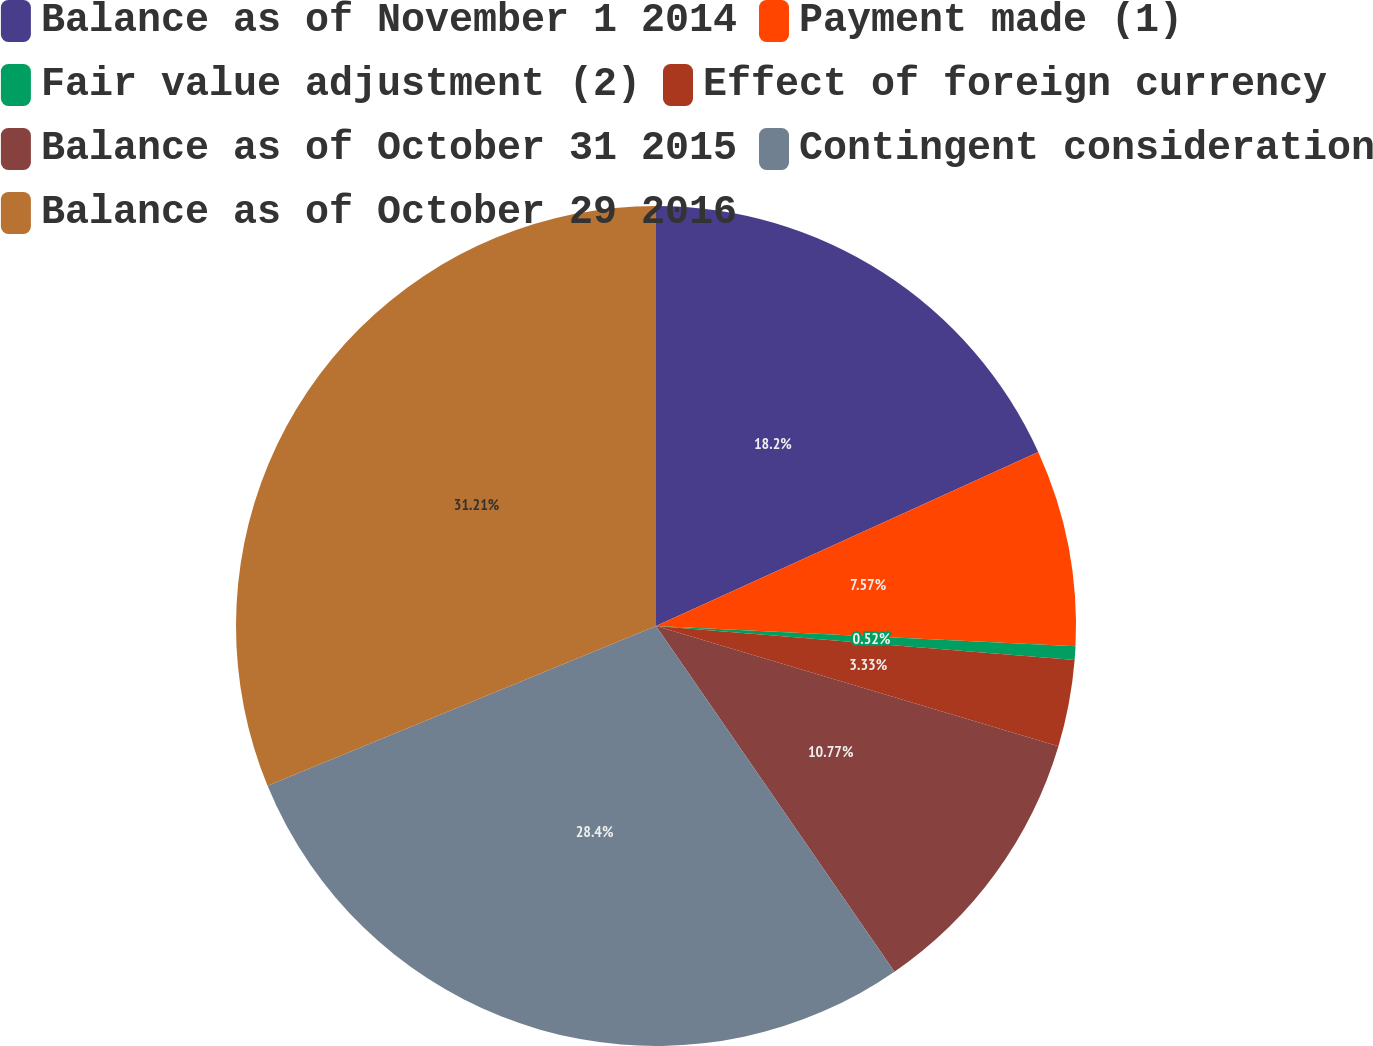Convert chart. <chart><loc_0><loc_0><loc_500><loc_500><pie_chart><fcel>Balance as of November 1 2014<fcel>Payment made (1)<fcel>Fair value adjustment (2)<fcel>Effect of foreign currency<fcel>Balance as of October 31 2015<fcel>Contingent consideration<fcel>Balance as of October 29 2016<nl><fcel>18.2%<fcel>7.57%<fcel>0.52%<fcel>3.33%<fcel>10.77%<fcel>28.4%<fcel>31.21%<nl></chart> 